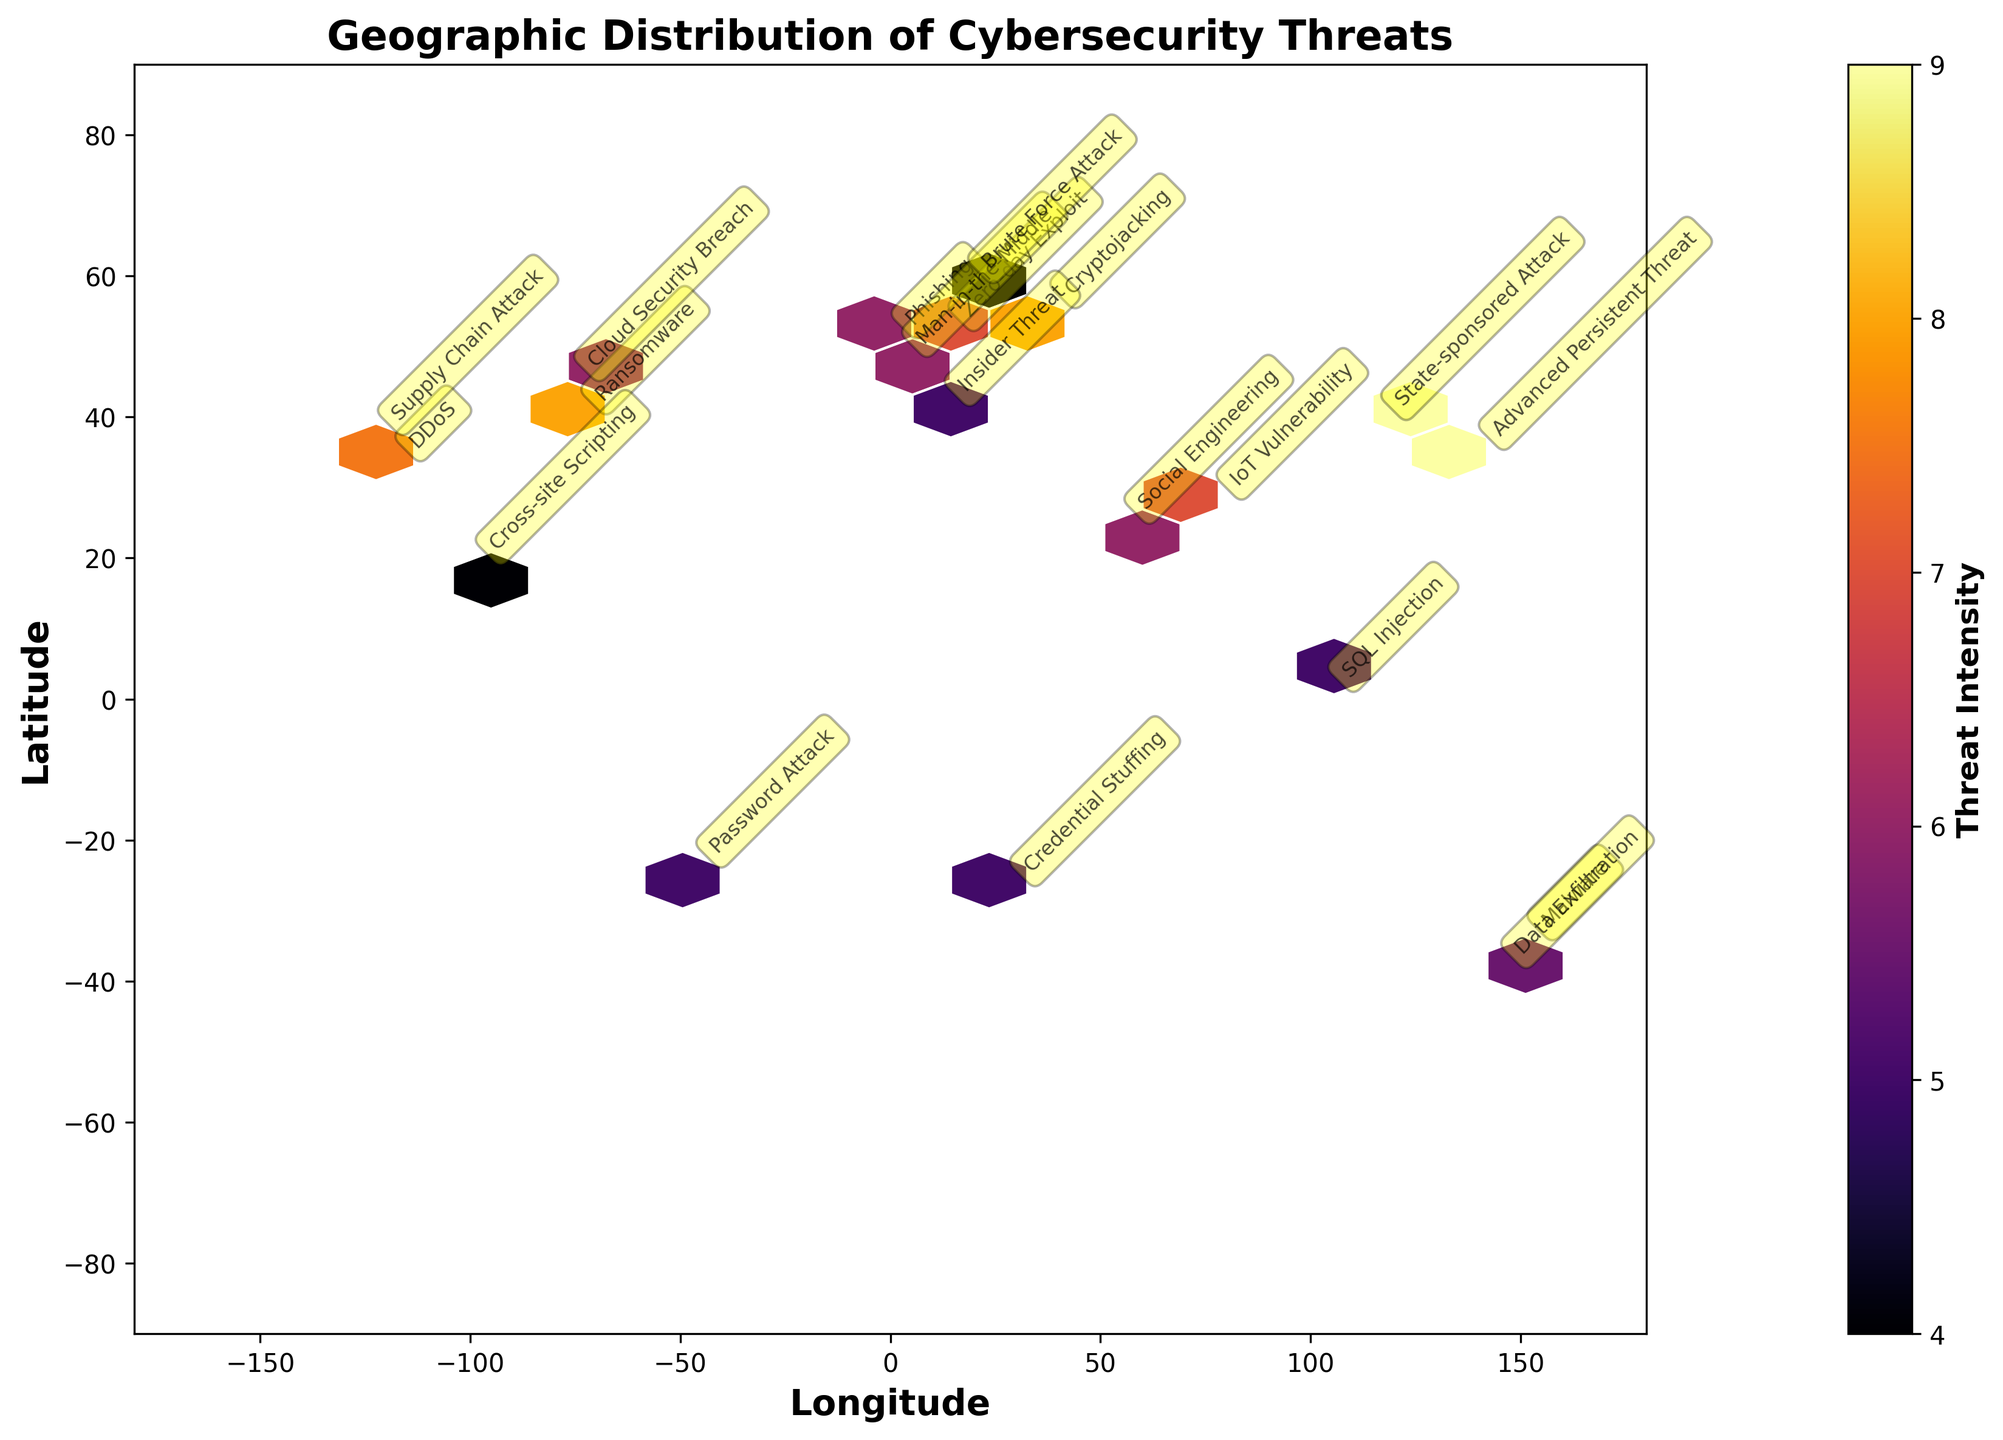What is the title of the plot? The title is usually placed at the top of the figure. In this plot, it reads "Geographic Distribution of Cybersecurity Threats".
Answer: Geographic Distribution of Cybersecurity Threats What are the labels for the x and y axes? Axes labels are usually written near the respective axes. The x-axis is labeled "Longitude" and the y-axis is labeled "Latitude".
Answer: Longitude and Latitude What does the color intensity represent in the hexbin plot? The color bar indicates the meaning of the color intensity. In this figure, the color bar shows that the intensity represents "Threat Intensity".
Answer: Threat Intensity Where is the highest threat intensity located? By looking for the darkest color in the plot and its location, we can identify the highest threat intensity. In this case, it is located around the coordinates corresponding to 39.9042° N, 116.4074° E (Beijing, China).
Answer: Beijing, China Which data point represents an Advanced Persistent Threat? We can identify it by the annotation box near the coordinates 35.6762° N, 139.6503° E (Tokyo, Japan), which notes "Advanced Persistent Threat".
Answer: Tokyo, Japan How many distinct threat types are labeled in the plot? By observing the different annotations placed on the plot, we can count the unique threat types. There are 18 distinct threat types shown.
Answer: 18 What is the average threat intensity for the plotted data points? By summing up the threat intensities (8 + 7 + 6 + 9 + 5 + 4 + 7 + 6 + 8 + 9 + 5 + 6 + 4 + 5 + 8 + 7 + 5 + 6 + 7 + 4) and dividing by the number of points (19), we get the average. Calculated: (Average intensity = 122 / 19)
Answer: 6.42 Are there more threat points in the Northern Hemisphere or the Southern Hemisphere? By visually dividing the plot at the equator (latitude 0°) and counting the data points in each hemisphere, we see more points in the Northern Hemisphere.
Answer: Northern Hemisphere Which coordinates have the lowest threat intensity, and what type of threat is it? The lowest threat intensity is represented by the lightest color in the plot. By locating this, we see it corresponds to the coordinates -33.8688° S, 151.2093° E and the type is "Malware".
Answer: Sydney, Australia, and Malware How does the geographic distribution of 'Phishing' compare to 'DDoS'? By looking for annotations labeled "Phishing" and "DDoS", 'Phishing' is located in London, UK, while 'DDoS' is found in Los Angeles, USA. Comparatively, they are located on different continents, with phishing threats in Europe and DDoS in North America.
Answer: Phishing in London and DDoS in Los Angeles 